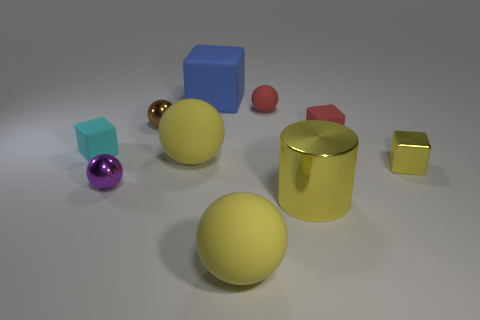Subtract all tiny matte balls. How many balls are left? 4 Subtract 2 balls. How many balls are left? 3 Subtract all brown spheres. How many spheres are left? 4 Subtract all cyan spheres. Subtract all red blocks. How many spheres are left? 5 Subtract all cubes. How many objects are left? 6 Add 6 cyan objects. How many cyan objects are left? 7 Add 3 shiny cubes. How many shiny cubes exist? 4 Subtract 1 red balls. How many objects are left? 9 Subtract all yellow spheres. Subtract all tiny brown shiny spheres. How many objects are left? 7 